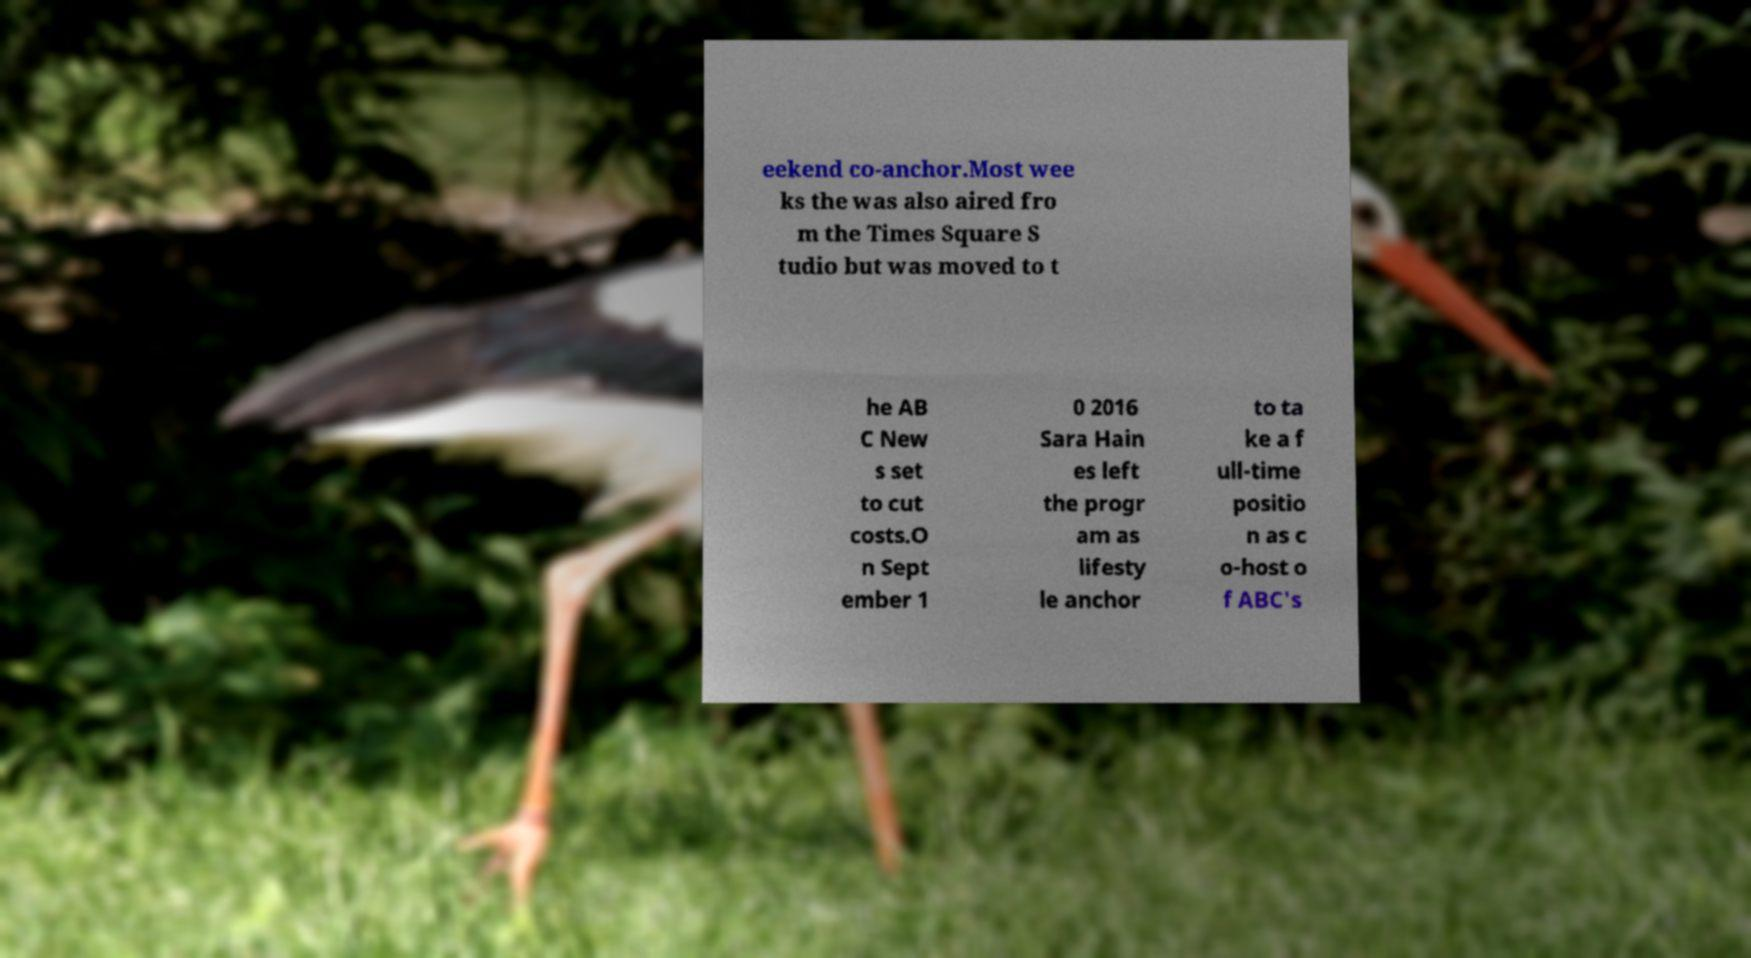I need the written content from this picture converted into text. Can you do that? eekend co-anchor.Most wee ks the was also aired fro m the Times Square S tudio but was moved to t he AB C New s set to cut costs.O n Sept ember 1 0 2016 Sara Hain es left the progr am as lifesty le anchor to ta ke a f ull-time positio n as c o-host o f ABC's 